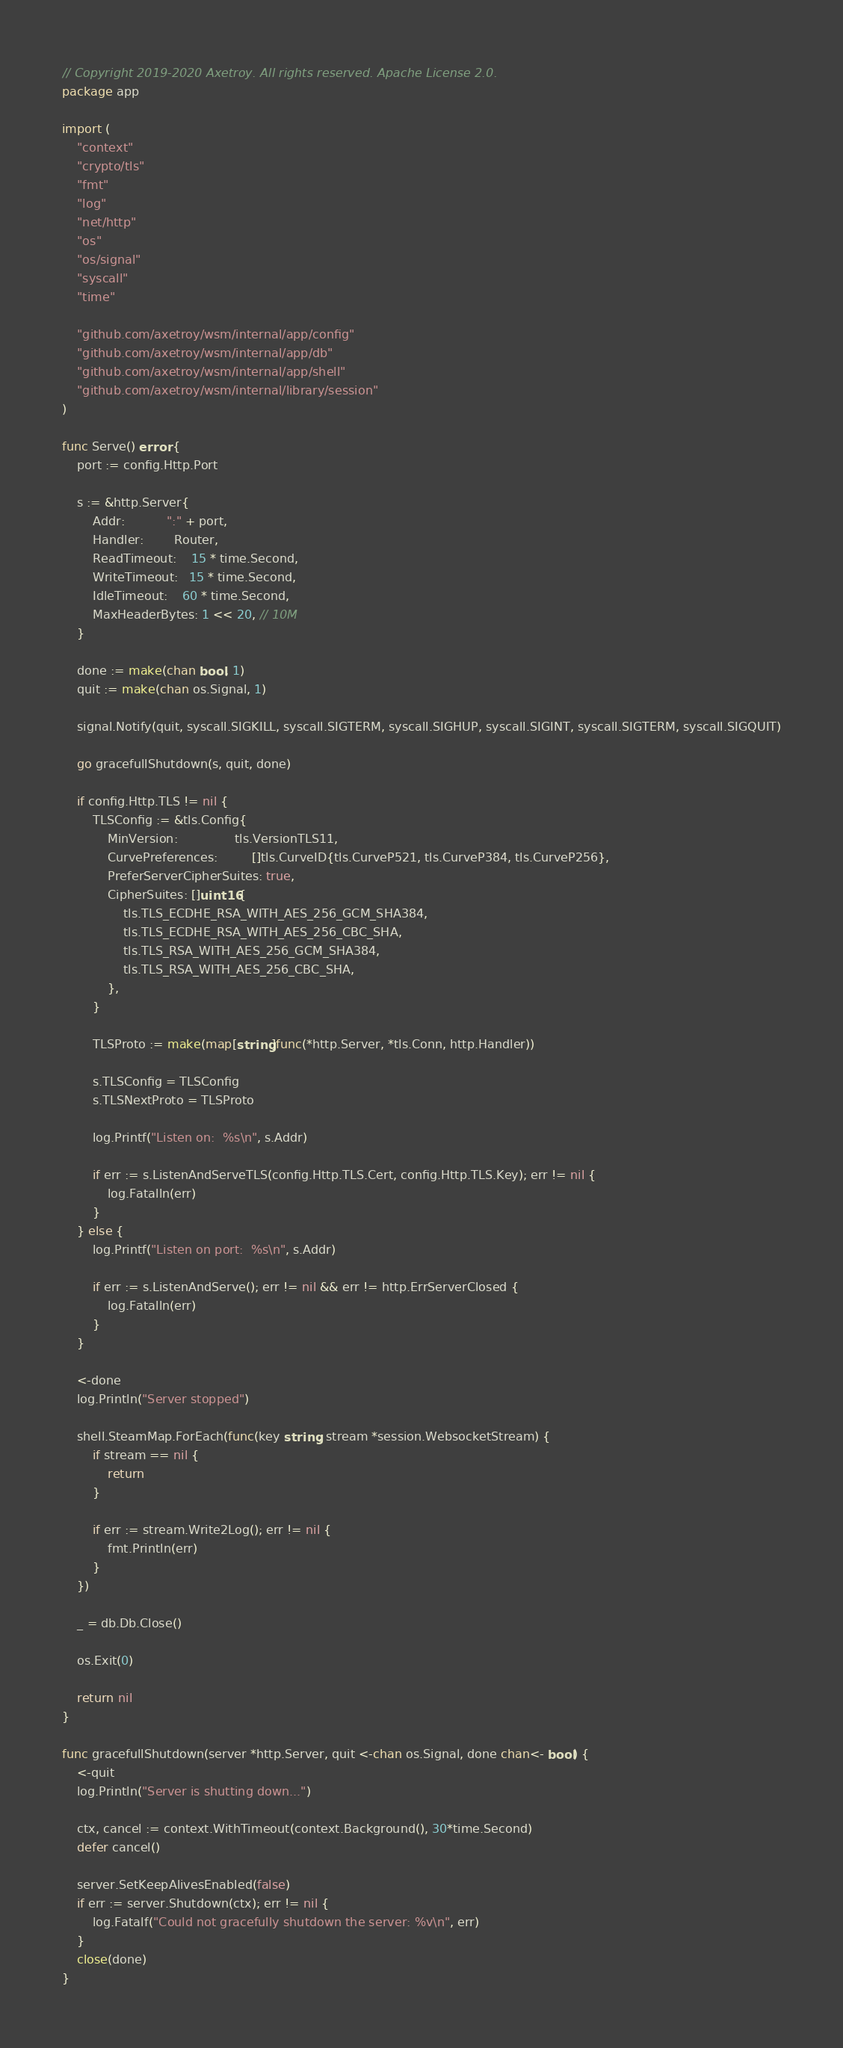Convert code to text. <code><loc_0><loc_0><loc_500><loc_500><_Go_>// Copyright 2019-2020 Axetroy. All rights reserved. Apache License 2.0.
package app

import (
	"context"
	"crypto/tls"
	"fmt"
	"log"
	"net/http"
	"os"
	"os/signal"
	"syscall"
	"time"

	"github.com/axetroy/wsm/internal/app/config"
	"github.com/axetroy/wsm/internal/app/db"
	"github.com/axetroy/wsm/internal/app/shell"
	"github.com/axetroy/wsm/internal/library/session"
)

func Serve() error {
	port := config.Http.Port

	s := &http.Server{
		Addr:           ":" + port,
		Handler:        Router,
		ReadTimeout:    15 * time.Second,
		WriteTimeout:   15 * time.Second,
		IdleTimeout:    60 * time.Second,
		MaxHeaderBytes: 1 << 20, // 10M
	}

	done := make(chan bool, 1)
	quit := make(chan os.Signal, 1)

	signal.Notify(quit, syscall.SIGKILL, syscall.SIGTERM, syscall.SIGHUP, syscall.SIGINT, syscall.SIGTERM, syscall.SIGQUIT)

	go gracefullShutdown(s, quit, done)

	if config.Http.TLS != nil {
		TLSConfig := &tls.Config{
			MinVersion:               tls.VersionTLS11,
			CurvePreferences:         []tls.CurveID{tls.CurveP521, tls.CurveP384, tls.CurveP256},
			PreferServerCipherSuites: true,
			CipherSuites: []uint16{
				tls.TLS_ECDHE_RSA_WITH_AES_256_GCM_SHA384,
				tls.TLS_ECDHE_RSA_WITH_AES_256_CBC_SHA,
				tls.TLS_RSA_WITH_AES_256_GCM_SHA384,
				tls.TLS_RSA_WITH_AES_256_CBC_SHA,
			},
		}

		TLSProto := make(map[string]func(*http.Server, *tls.Conn, http.Handler))

		s.TLSConfig = TLSConfig
		s.TLSNextProto = TLSProto

		log.Printf("Listen on:  %s\n", s.Addr)

		if err := s.ListenAndServeTLS(config.Http.TLS.Cert, config.Http.TLS.Key); err != nil {
			log.Fatalln(err)
		}
	} else {
		log.Printf("Listen on port:  %s\n", s.Addr)

		if err := s.ListenAndServe(); err != nil && err != http.ErrServerClosed {
			log.Fatalln(err)
		}
	}

	<-done
	log.Println("Server stopped")

	shell.SteamMap.ForEach(func(key string, stream *session.WebsocketStream) {
		if stream == nil {
			return
		}

		if err := stream.Write2Log(); err != nil {
			fmt.Println(err)
		}
	})

	_ = db.Db.Close()

	os.Exit(0)

	return nil
}

func gracefullShutdown(server *http.Server, quit <-chan os.Signal, done chan<- bool) {
	<-quit
	log.Println("Server is shutting down...")

	ctx, cancel := context.WithTimeout(context.Background(), 30*time.Second)
	defer cancel()

	server.SetKeepAlivesEnabled(false)
	if err := server.Shutdown(ctx); err != nil {
		log.Fatalf("Could not gracefully shutdown the server: %v\n", err)
	}
	close(done)
}
</code> 